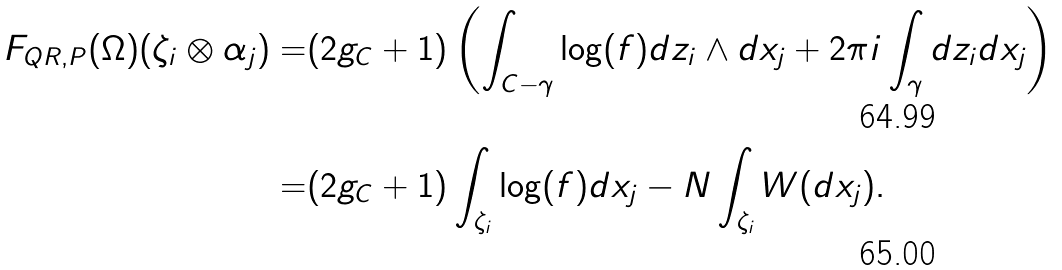Convert formula to latex. <formula><loc_0><loc_0><loc_500><loc_500>F _ { Q R , P } ( \Omega ) ( \zeta _ { i } \otimes \alpha _ { j } ) = & ( 2 g _ { C } + 1 ) \left ( \int _ { C - \gamma } \log ( f ) d z _ { i } \wedge d x _ { j } + 2 \pi i \int _ { \gamma } d z _ { i } d x _ { j } \right ) \\ = & ( 2 g _ { C } + 1 ) \int _ { \zeta _ { i } } \log ( f ) d x _ { j } - N \int _ { \zeta _ { i } } W ( d x _ { j } ) .</formula> 